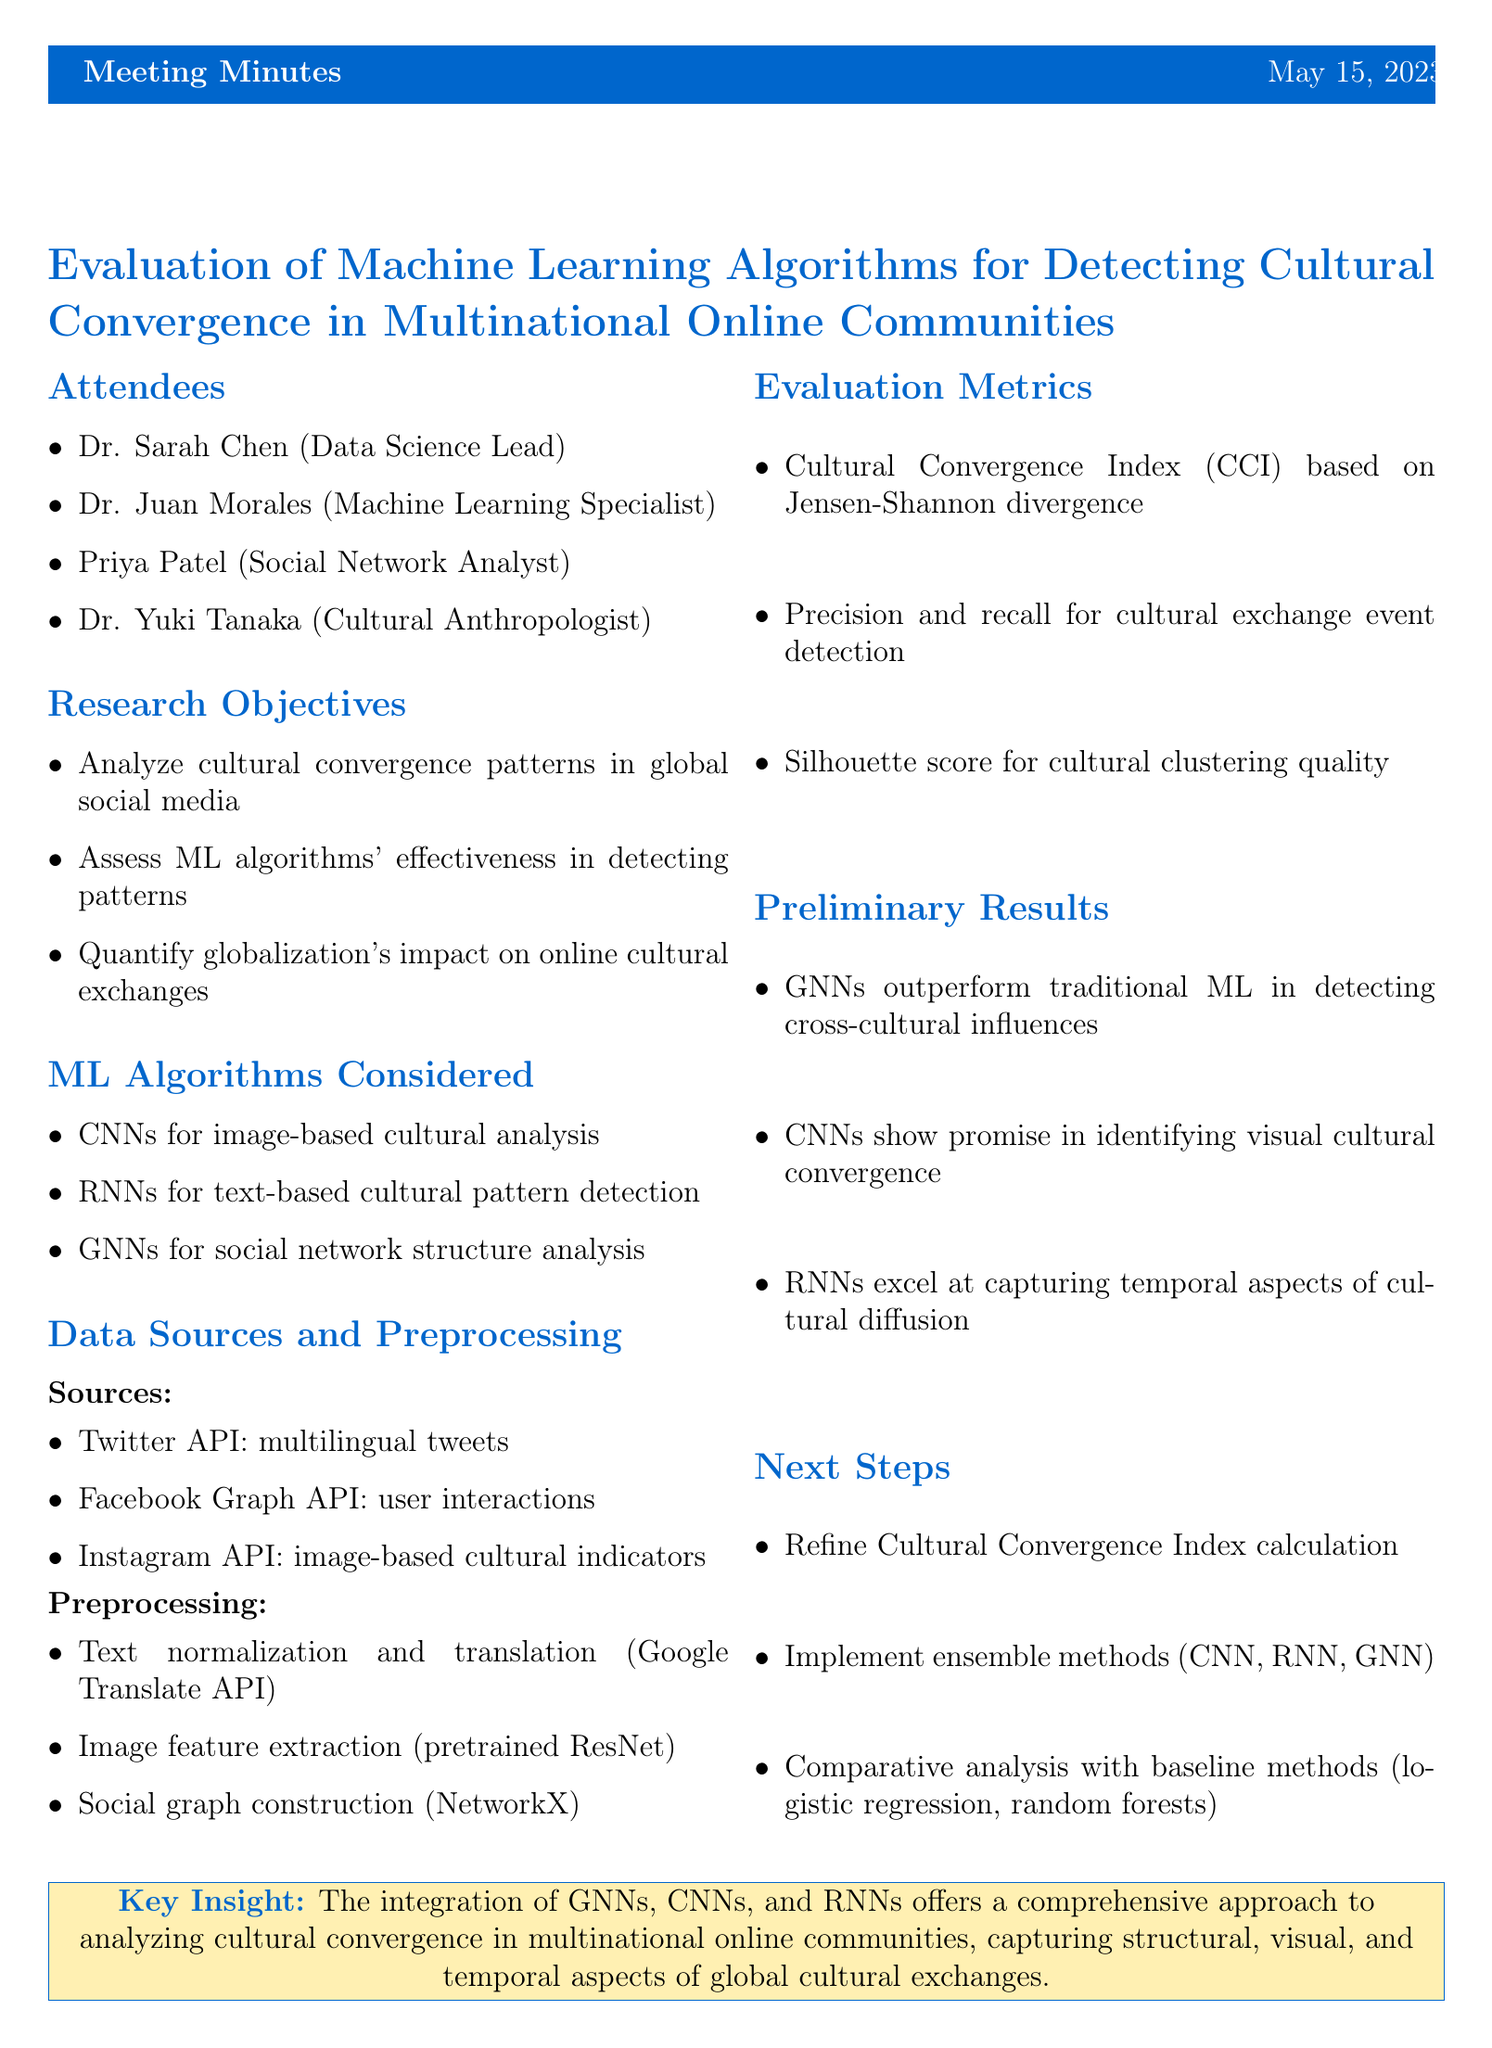What is the date of the meeting? The date is explicitly stated in the document as the day of the meeting.
Answer: 2023-05-15 Who is the Data Science Lead? The document lists attendees and their roles, specifically noting the Data Science Lead.
Answer: Dr. Sarah Chen What machine learning algorithm is used for image-based cultural analysis? The section on machine learning algorithms outlines their respective applications briefly.
Answer: Convolutional Neural Networks What is the primary data source for multilingual tweet collection? The document mentions specific data sources in relation to social media data collection.
Answer: Twitter API Which evaluation metric is based on Jensen-Shannon divergence? The evaluation metrics include specific measures, with one described as being derived from a statistical method.
Answer: Cultural Convergence Index What does GNN stand for? The machine learning algorithms section provides acronyms for the algorithms used in the analysis.
Answer: Graph Neural Networks What is one of the preliminary findings regarding GNNs? The preliminary results section summarizes insights gained from the analysis of the algorithms applied.
Answer: outperform traditional ML methods What is one of the next steps mentioned in the meeting? The document outlines planned future actions based on the meeting's discussions.
Answer: Refine the Cultural Convergence Index calculation 